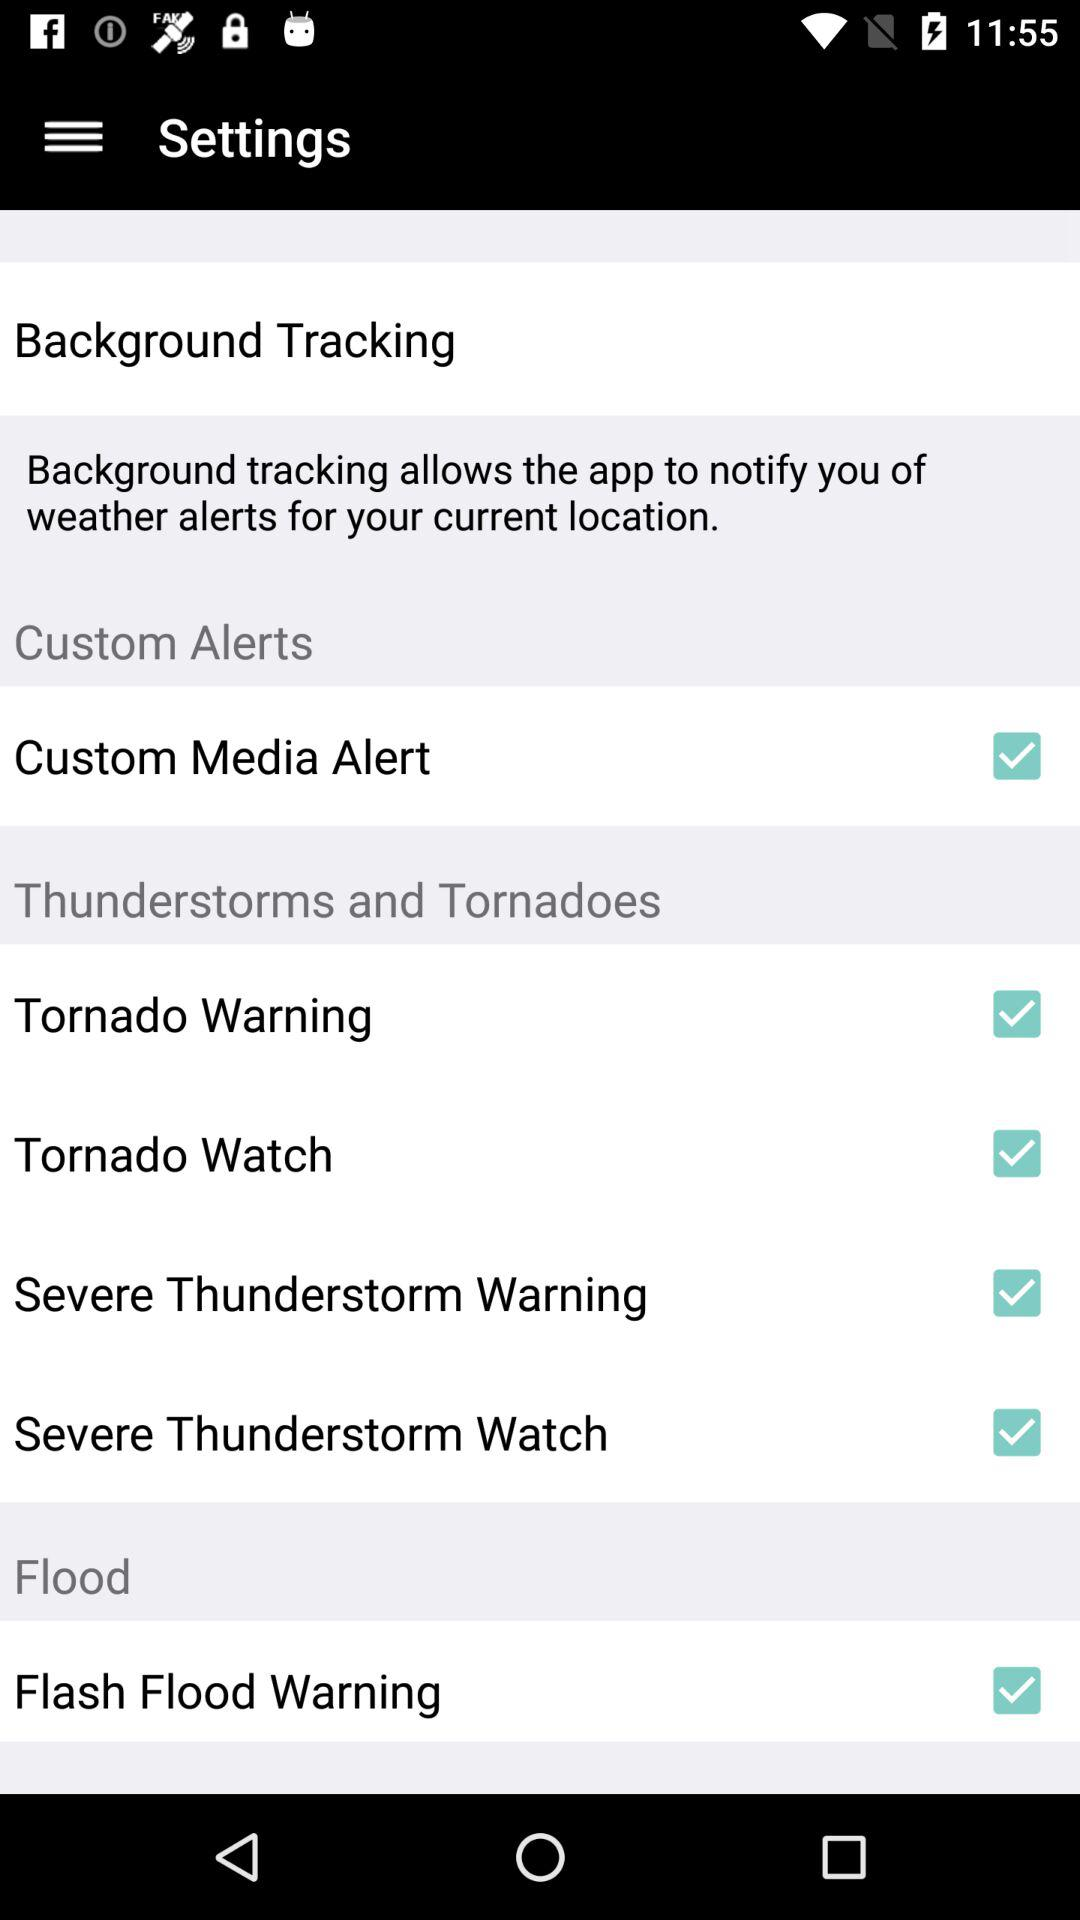How many alert types are there?
Answer the question using a single word or phrase. 6 